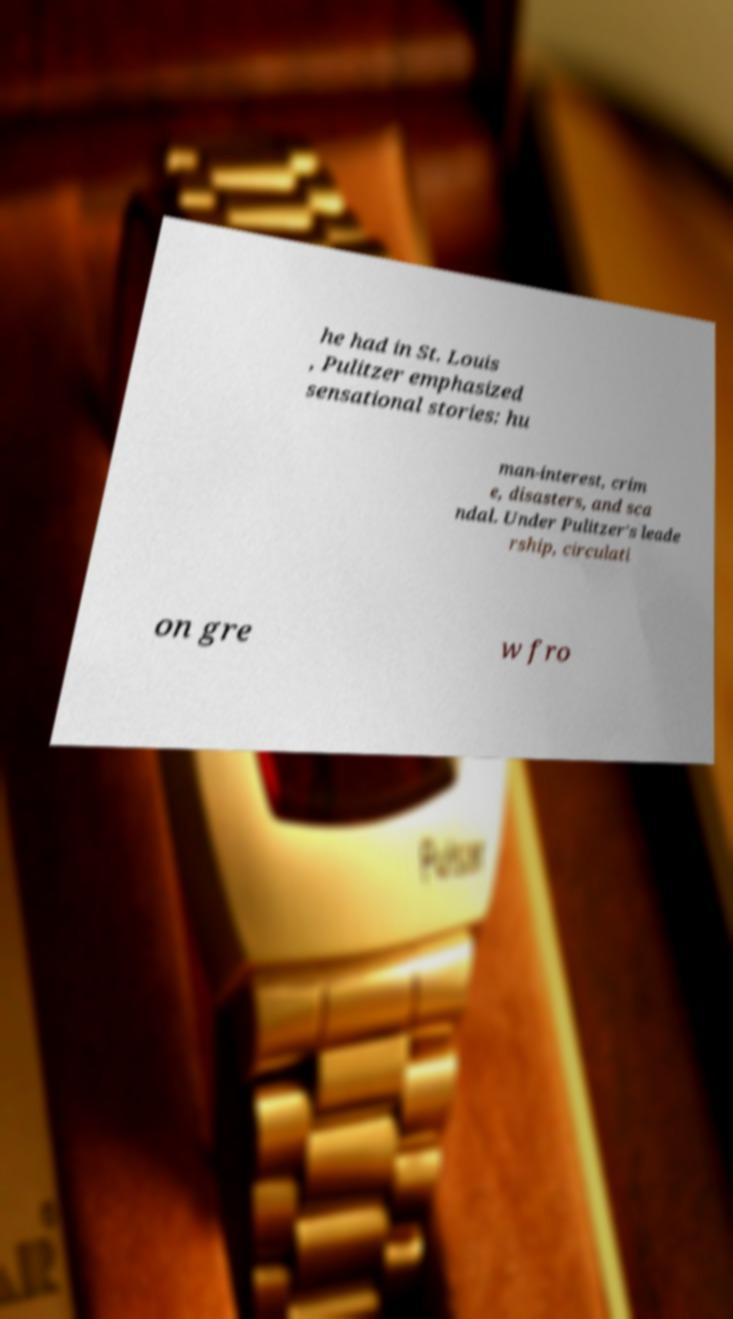What messages or text are displayed in this image? I need them in a readable, typed format. he had in St. Louis , Pulitzer emphasized sensational stories: hu man-interest, crim e, disasters, and sca ndal. Under Pulitzer's leade rship, circulati on gre w fro 